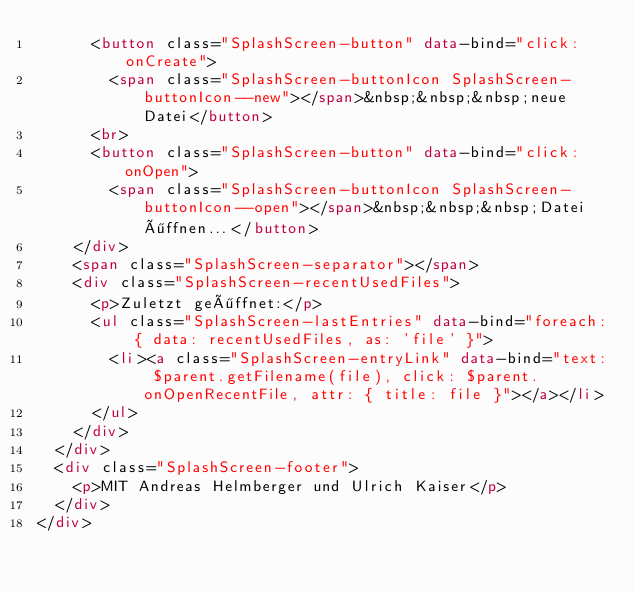<code> <loc_0><loc_0><loc_500><loc_500><_HTML_>      <button class="SplashScreen-button" data-bind="click: onCreate">
        <span class="SplashScreen-buttonIcon SplashScreen-buttonIcon--new"></span>&nbsp;&nbsp;&nbsp;neue Datei</button>
      <br>
      <button class="SplashScreen-button" data-bind="click: onOpen">
        <span class="SplashScreen-buttonIcon SplashScreen-buttonIcon--open"></span>&nbsp;&nbsp;&nbsp;Datei öffnen...</button>
    </div>
    <span class="SplashScreen-separator"></span>
    <div class="SplashScreen-recentUsedFiles">
      <p>Zuletzt geöffnet:</p>
      <ul class="SplashScreen-lastEntries" data-bind="foreach: { data: recentUsedFiles, as: 'file' }">
        <li><a class="SplashScreen-entryLink" data-bind="text: $parent.getFilename(file), click: $parent.onOpenRecentFile, attr: { title: file }"></a></li>
      </ul>
    </div>
  </div>
  <div class="SplashScreen-footer">
    <p>MIT Andreas Helmberger und Ulrich Kaiser</p>
  </div>
</div>
</code> 